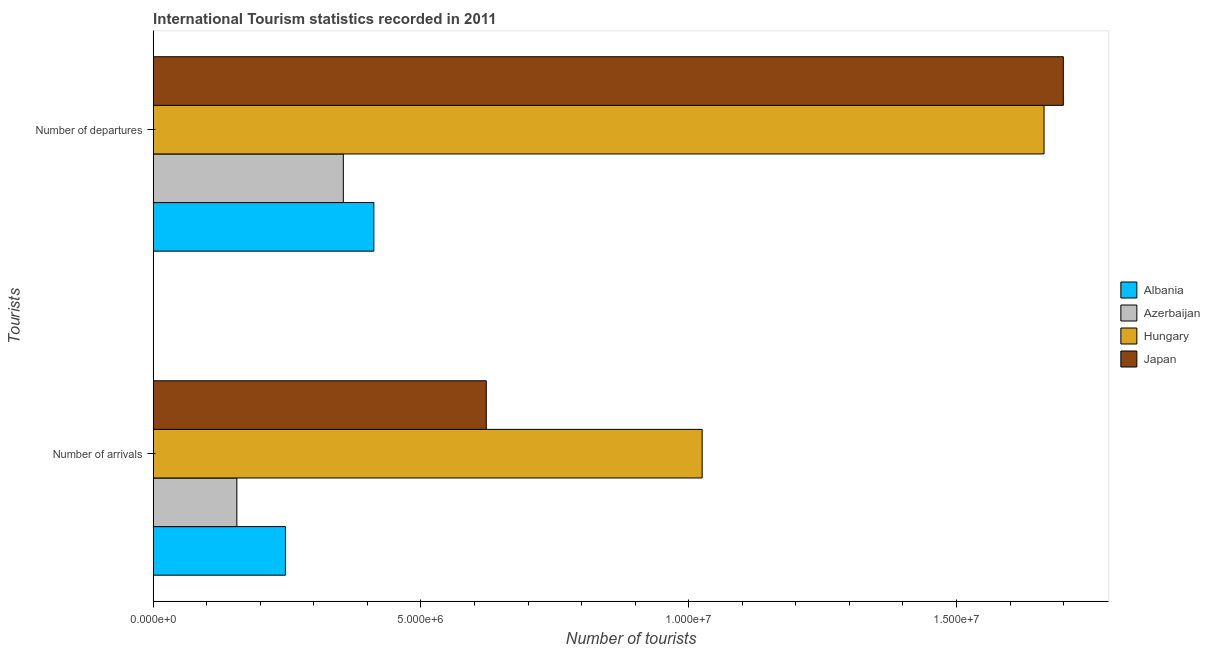How many groups of bars are there?
Provide a succinct answer. 2. Are the number of bars per tick equal to the number of legend labels?
Ensure brevity in your answer.  Yes. How many bars are there on the 2nd tick from the bottom?
Provide a succinct answer. 4. What is the label of the 1st group of bars from the top?
Ensure brevity in your answer.  Number of departures. What is the number of tourist arrivals in Azerbaijan?
Offer a terse response. 1.56e+06. Across all countries, what is the maximum number of tourist arrivals?
Ensure brevity in your answer.  1.02e+07. Across all countries, what is the minimum number of tourist departures?
Give a very brief answer. 3.55e+06. In which country was the number of tourist arrivals minimum?
Provide a short and direct response. Azerbaijan. What is the total number of tourist arrivals in the graph?
Give a very brief answer. 2.05e+07. What is the difference between the number of tourist departures in Azerbaijan and that in Hungary?
Your answer should be very brief. -1.31e+07. What is the difference between the number of tourist departures in Azerbaijan and the number of tourist arrivals in Albania?
Keep it short and to the point. 1.08e+06. What is the average number of tourist arrivals per country?
Keep it short and to the point. 5.12e+06. What is the difference between the number of tourist arrivals and number of tourist departures in Hungary?
Your answer should be very brief. -6.38e+06. In how many countries, is the number of tourist departures greater than 10000000 ?
Offer a terse response. 2. What is the ratio of the number of tourist departures in Albania to that in Azerbaijan?
Ensure brevity in your answer.  1.16. What does the 3rd bar from the top in Number of departures represents?
Offer a very short reply. Azerbaijan. What does the 2nd bar from the bottom in Number of arrivals represents?
Provide a succinct answer. Azerbaijan. How many countries are there in the graph?
Your response must be concise. 4. Are the values on the major ticks of X-axis written in scientific E-notation?
Your answer should be very brief. Yes. Does the graph contain any zero values?
Keep it short and to the point. No. Does the graph contain grids?
Offer a very short reply. No. Where does the legend appear in the graph?
Offer a very short reply. Center right. How many legend labels are there?
Provide a succinct answer. 4. How are the legend labels stacked?
Your response must be concise. Vertical. What is the title of the graph?
Provide a succinct answer. International Tourism statistics recorded in 2011. Does "Malawi" appear as one of the legend labels in the graph?
Provide a succinct answer. No. What is the label or title of the X-axis?
Provide a short and direct response. Number of tourists. What is the label or title of the Y-axis?
Offer a very short reply. Tourists. What is the Number of tourists of Albania in Number of arrivals?
Your answer should be very brief. 2.47e+06. What is the Number of tourists in Azerbaijan in Number of arrivals?
Offer a very short reply. 1.56e+06. What is the Number of tourists in Hungary in Number of arrivals?
Your response must be concise. 1.02e+07. What is the Number of tourists of Japan in Number of arrivals?
Your response must be concise. 6.22e+06. What is the Number of tourists in Albania in Number of departures?
Make the answer very short. 4.12e+06. What is the Number of tourists in Azerbaijan in Number of departures?
Your answer should be compact. 3.55e+06. What is the Number of tourists of Hungary in Number of departures?
Your answer should be very brief. 1.66e+07. What is the Number of tourists in Japan in Number of departures?
Offer a terse response. 1.70e+07. Across all Tourists, what is the maximum Number of tourists of Albania?
Give a very brief answer. 4.12e+06. Across all Tourists, what is the maximum Number of tourists in Azerbaijan?
Make the answer very short. 3.55e+06. Across all Tourists, what is the maximum Number of tourists of Hungary?
Your response must be concise. 1.66e+07. Across all Tourists, what is the maximum Number of tourists in Japan?
Offer a very short reply. 1.70e+07. Across all Tourists, what is the minimum Number of tourists of Albania?
Provide a short and direct response. 2.47e+06. Across all Tourists, what is the minimum Number of tourists of Azerbaijan?
Ensure brevity in your answer.  1.56e+06. Across all Tourists, what is the minimum Number of tourists of Hungary?
Your response must be concise. 1.02e+07. Across all Tourists, what is the minimum Number of tourists of Japan?
Ensure brevity in your answer.  6.22e+06. What is the total Number of tourists in Albania in the graph?
Your response must be concise. 6.59e+06. What is the total Number of tourists in Azerbaijan in the graph?
Offer a terse response. 5.11e+06. What is the total Number of tourists in Hungary in the graph?
Offer a terse response. 2.69e+07. What is the total Number of tourists in Japan in the graph?
Keep it short and to the point. 2.32e+07. What is the difference between the Number of tourists in Albania in Number of arrivals and that in Number of departures?
Your response must be concise. -1.65e+06. What is the difference between the Number of tourists of Azerbaijan in Number of arrivals and that in Number of departures?
Offer a terse response. -1.99e+06. What is the difference between the Number of tourists in Hungary in Number of arrivals and that in Number of departures?
Your answer should be compact. -6.38e+06. What is the difference between the Number of tourists of Japan in Number of arrivals and that in Number of departures?
Keep it short and to the point. -1.08e+07. What is the difference between the Number of tourists in Albania in Number of arrivals and the Number of tourists in Azerbaijan in Number of departures?
Ensure brevity in your answer.  -1.08e+06. What is the difference between the Number of tourists of Albania in Number of arrivals and the Number of tourists of Hungary in Number of departures?
Provide a short and direct response. -1.42e+07. What is the difference between the Number of tourists of Albania in Number of arrivals and the Number of tourists of Japan in Number of departures?
Offer a terse response. -1.45e+07. What is the difference between the Number of tourists of Azerbaijan in Number of arrivals and the Number of tourists of Hungary in Number of departures?
Provide a succinct answer. -1.51e+07. What is the difference between the Number of tourists in Azerbaijan in Number of arrivals and the Number of tourists in Japan in Number of departures?
Ensure brevity in your answer.  -1.54e+07. What is the difference between the Number of tourists of Hungary in Number of arrivals and the Number of tourists of Japan in Number of departures?
Ensure brevity in your answer.  -6.74e+06. What is the average Number of tourists in Albania per Tourists?
Your response must be concise. 3.29e+06. What is the average Number of tourists in Azerbaijan per Tourists?
Provide a succinct answer. 2.56e+06. What is the average Number of tourists in Hungary per Tourists?
Make the answer very short. 1.34e+07. What is the average Number of tourists in Japan per Tourists?
Provide a succinct answer. 1.16e+07. What is the difference between the Number of tourists of Albania and Number of tourists of Azerbaijan in Number of arrivals?
Provide a succinct answer. 9.07e+05. What is the difference between the Number of tourists in Albania and Number of tourists in Hungary in Number of arrivals?
Your response must be concise. -7.78e+06. What is the difference between the Number of tourists of Albania and Number of tourists of Japan in Number of arrivals?
Keep it short and to the point. -3.75e+06. What is the difference between the Number of tourists of Azerbaijan and Number of tourists of Hungary in Number of arrivals?
Your answer should be compact. -8.69e+06. What is the difference between the Number of tourists in Azerbaijan and Number of tourists in Japan in Number of arrivals?
Give a very brief answer. -4.66e+06. What is the difference between the Number of tourists of Hungary and Number of tourists of Japan in Number of arrivals?
Your answer should be very brief. 4.03e+06. What is the difference between the Number of tourists in Albania and Number of tourists in Azerbaijan in Number of departures?
Make the answer very short. 5.70e+05. What is the difference between the Number of tourists in Albania and Number of tourists in Hungary in Number of departures?
Your response must be concise. -1.25e+07. What is the difference between the Number of tourists of Albania and Number of tourists of Japan in Number of departures?
Ensure brevity in your answer.  -1.29e+07. What is the difference between the Number of tourists in Azerbaijan and Number of tourists in Hungary in Number of departures?
Give a very brief answer. -1.31e+07. What is the difference between the Number of tourists in Azerbaijan and Number of tourists in Japan in Number of departures?
Offer a terse response. -1.34e+07. What is the difference between the Number of tourists of Hungary and Number of tourists of Japan in Number of departures?
Ensure brevity in your answer.  -3.60e+05. What is the ratio of the Number of tourists in Albania in Number of arrivals to that in Number of departures?
Your answer should be very brief. 0.6. What is the ratio of the Number of tourists in Azerbaijan in Number of arrivals to that in Number of departures?
Your answer should be very brief. 0.44. What is the ratio of the Number of tourists in Hungary in Number of arrivals to that in Number of departures?
Keep it short and to the point. 0.62. What is the ratio of the Number of tourists of Japan in Number of arrivals to that in Number of departures?
Provide a short and direct response. 0.37. What is the difference between the highest and the second highest Number of tourists in Albania?
Make the answer very short. 1.65e+06. What is the difference between the highest and the second highest Number of tourists in Azerbaijan?
Your answer should be very brief. 1.99e+06. What is the difference between the highest and the second highest Number of tourists in Hungary?
Your answer should be very brief. 6.38e+06. What is the difference between the highest and the second highest Number of tourists of Japan?
Provide a succinct answer. 1.08e+07. What is the difference between the highest and the lowest Number of tourists in Albania?
Ensure brevity in your answer.  1.65e+06. What is the difference between the highest and the lowest Number of tourists in Azerbaijan?
Ensure brevity in your answer.  1.99e+06. What is the difference between the highest and the lowest Number of tourists of Hungary?
Ensure brevity in your answer.  6.38e+06. What is the difference between the highest and the lowest Number of tourists in Japan?
Keep it short and to the point. 1.08e+07. 